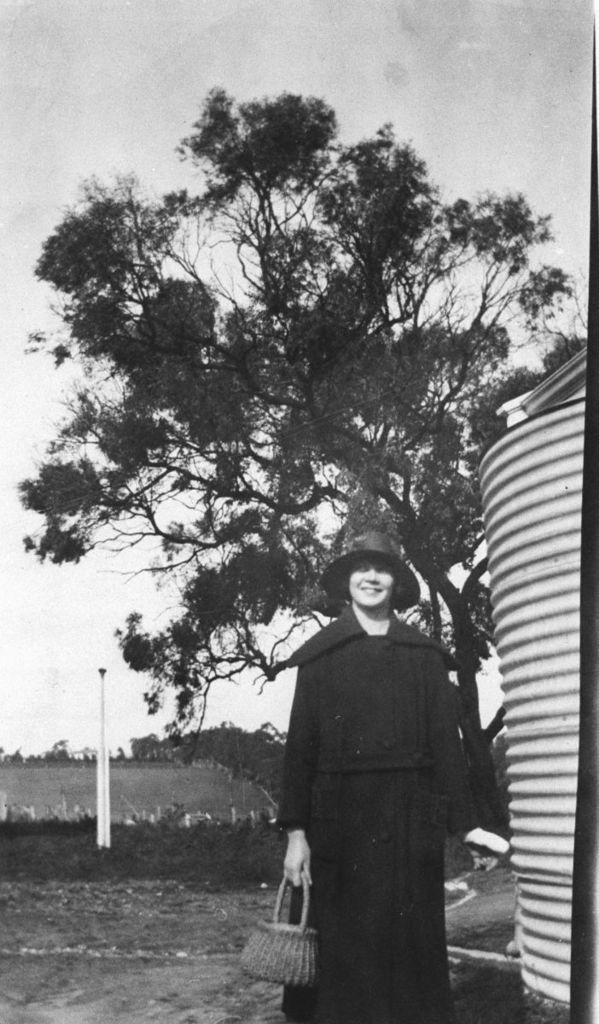Who is present in the image? There is a lady in the image. What is the lady holding in the image? The lady is holding a basket. What can be seen in the background of the image? There are trees and a tank in the background of the image. What grade is the lady teaching in the image? There is no indication in the image that the lady is a teacher, nor is there any mention of a grade. 